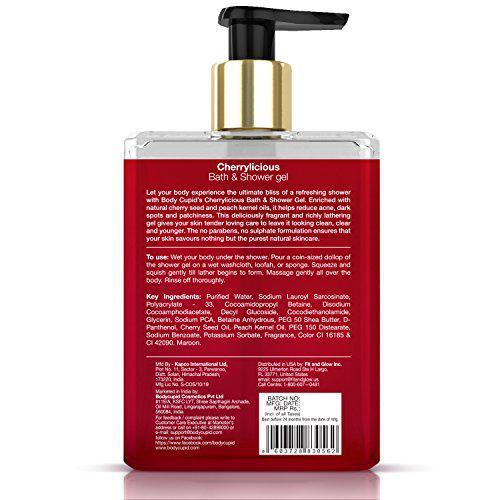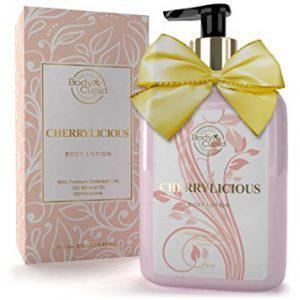The first image is the image on the left, the second image is the image on the right. Considering the images on both sides, is "Each image contains exactly one product with a black pump top, and one image features a pump bottle with a yellow bow, but the pump nozzles on the left and right face different directions." valid? Answer yes or no. Yes. 